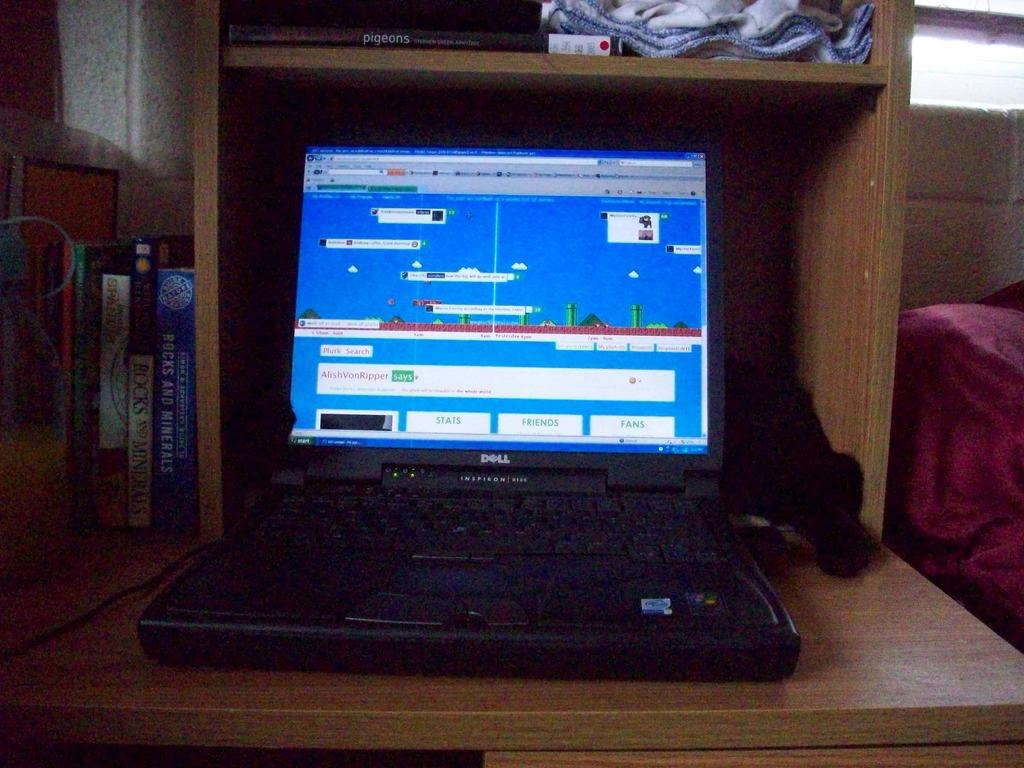<image>
Give a short and clear explanation of the subsequent image. A laptop sits on a desk labeled DELL INSPIRON. 